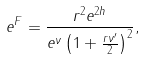Convert formula to latex. <formula><loc_0><loc_0><loc_500><loc_500>e ^ { F } = \frac { r ^ { 2 } e ^ { 2 h } } { e ^ { \nu } \left ( 1 + \frac { r \nu ^ { \prime } } 2 \right ) ^ { 2 } } ,</formula> 